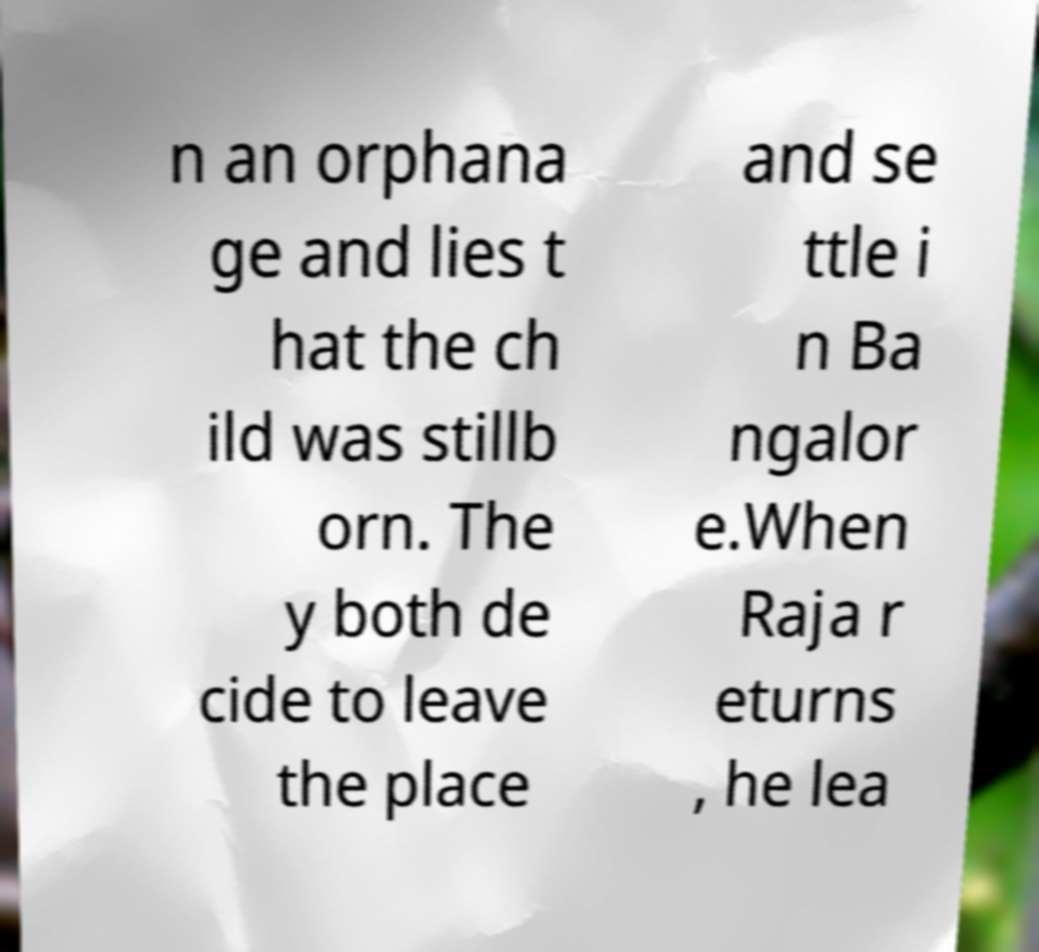There's text embedded in this image that I need extracted. Can you transcribe it verbatim? n an orphana ge and lies t hat the ch ild was stillb orn. The y both de cide to leave the place and se ttle i n Ba ngalor e.When Raja r eturns , he lea 